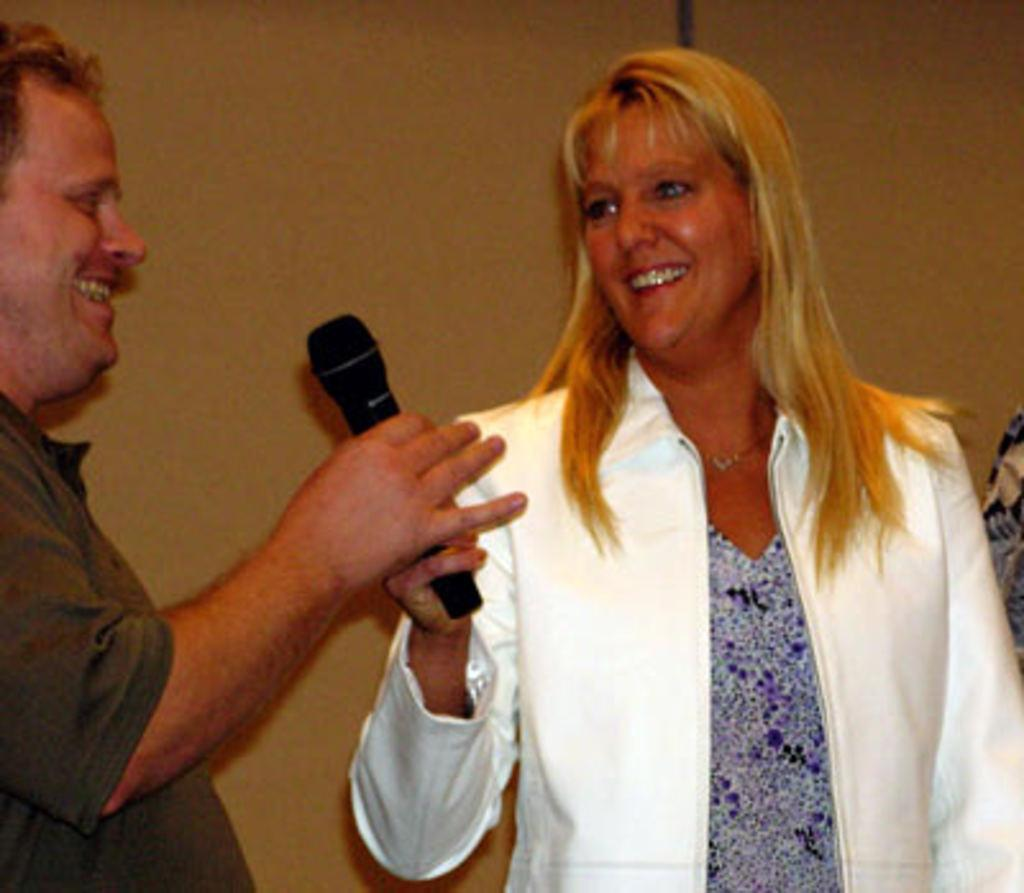What is the main subject of the image? The main subjects of the image are a guy and a lady. What is the guy holding in the image? The guy is holding a mic in one of his hands. What is the lady doing in the image? The lady is taking the mic from the guy. What type of bee can be seen flying around the guy in the image? There are no bees present in the image; it only features a guy and a lady interacting with a mic. 